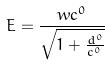Convert formula to latex. <formula><loc_0><loc_0><loc_500><loc_500>E = \frac { w c ^ { 0 } } { \sqrt { 1 + \frac { d ^ { 0 } } { c ^ { 0 } } } }</formula> 